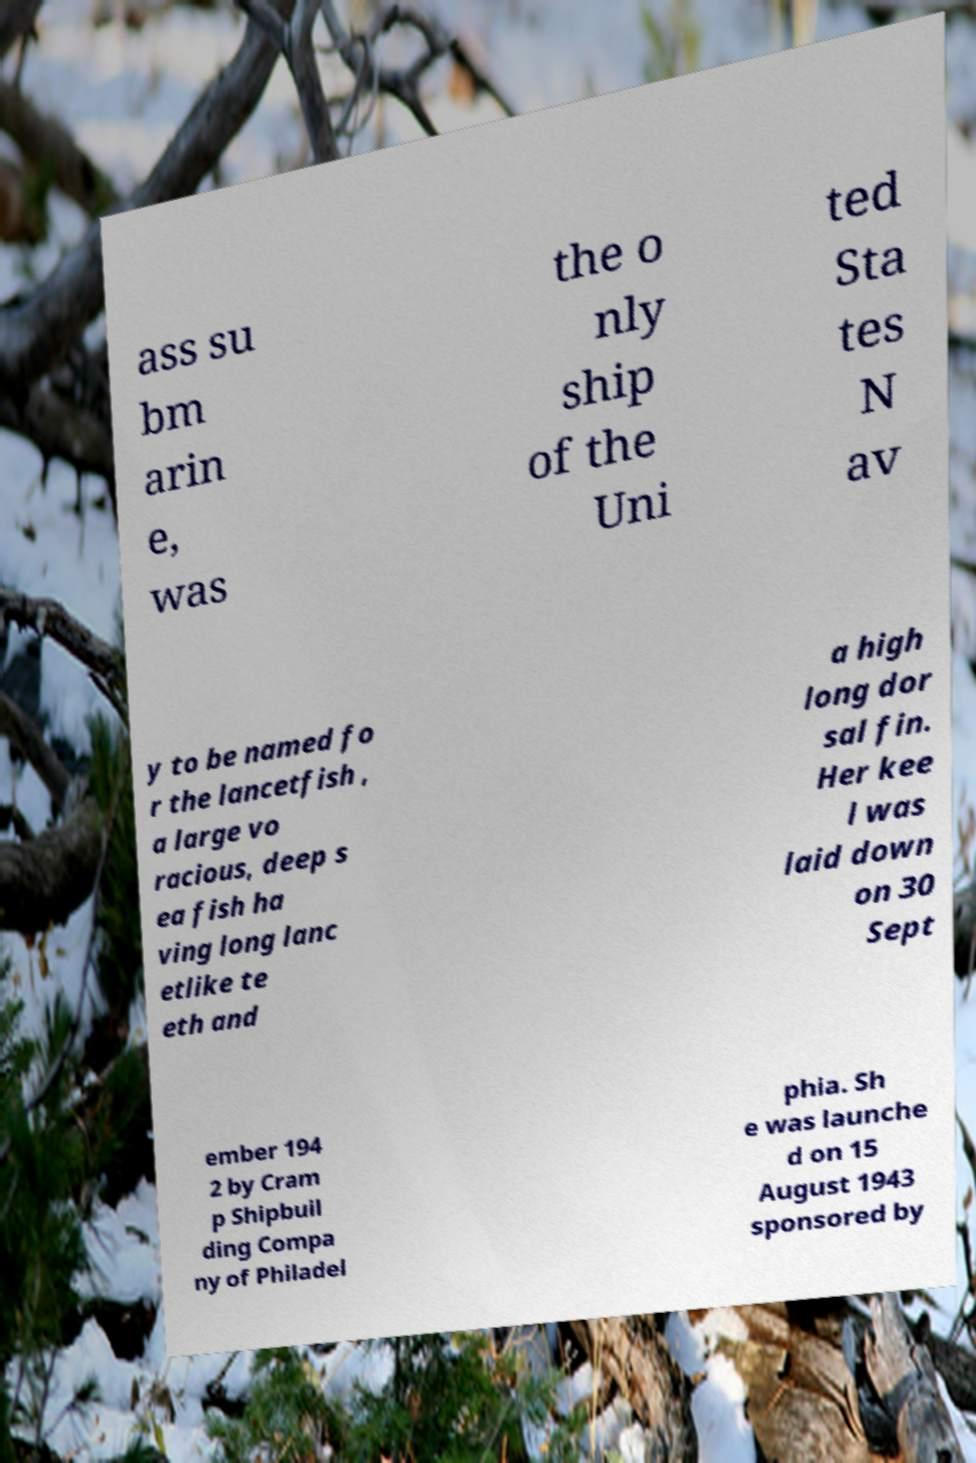Could you extract and type out the text from this image? ass su bm arin e, was the o nly ship of the Uni ted Sta tes N av y to be named fo r the lancetfish , a large vo racious, deep s ea fish ha ving long lanc etlike te eth and a high long dor sal fin. Her kee l was laid down on 30 Sept ember 194 2 by Cram p Shipbuil ding Compa ny of Philadel phia. Sh e was launche d on 15 August 1943 sponsored by 